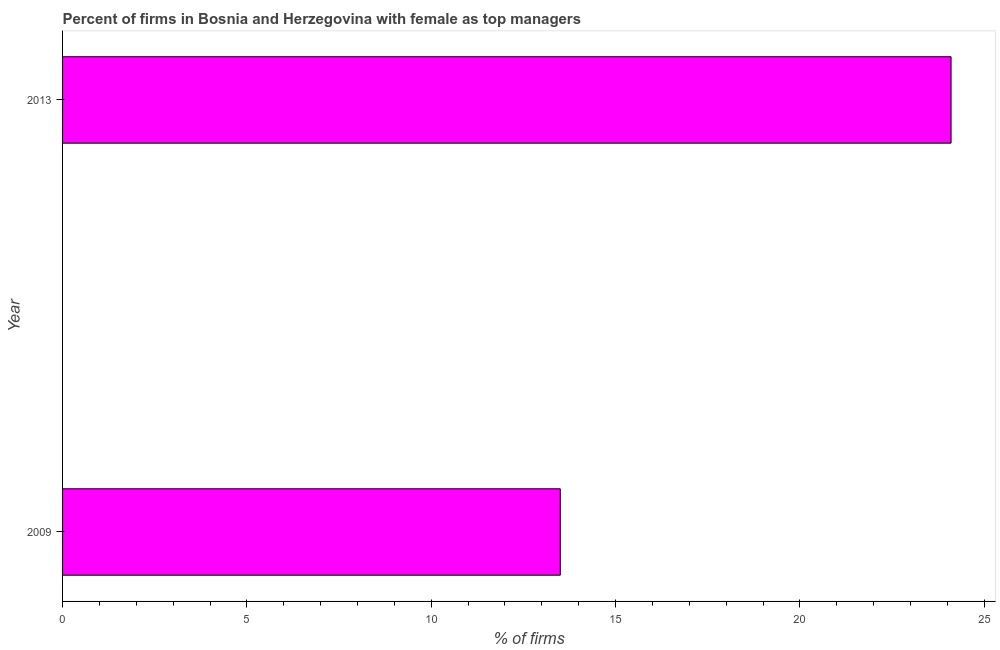Does the graph contain any zero values?
Offer a very short reply. No. Does the graph contain grids?
Provide a short and direct response. No. What is the title of the graph?
Your response must be concise. Percent of firms in Bosnia and Herzegovina with female as top managers. What is the label or title of the X-axis?
Offer a terse response. % of firms. What is the percentage of firms with female as top manager in 2013?
Give a very brief answer. 24.1. Across all years, what is the maximum percentage of firms with female as top manager?
Your response must be concise. 24.1. Across all years, what is the minimum percentage of firms with female as top manager?
Give a very brief answer. 13.5. In which year was the percentage of firms with female as top manager maximum?
Your answer should be very brief. 2013. What is the sum of the percentage of firms with female as top manager?
Your answer should be very brief. 37.6. What is the median percentage of firms with female as top manager?
Offer a terse response. 18.8. In how many years, is the percentage of firms with female as top manager greater than 2 %?
Give a very brief answer. 2. What is the ratio of the percentage of firms with female as top manager in 2009 to that in 2013?
Make the answer very short. 0.56. How many years are there in the graph?
Provide a succinct answer. 2. Are the values on the major ticks of X-axis written in scientific E-notation?
Ensure brevity in your answer.  No. What is the % of firms of 2013?
Ensure brevity in your answer.  24.1. What is the difference between the % of firms in 2009 and 2013?
Your answer should be compact. -10.6. What is the ratio of the % of firms in 2009 to that in 2013?
Your response must be concise. 0.56. 